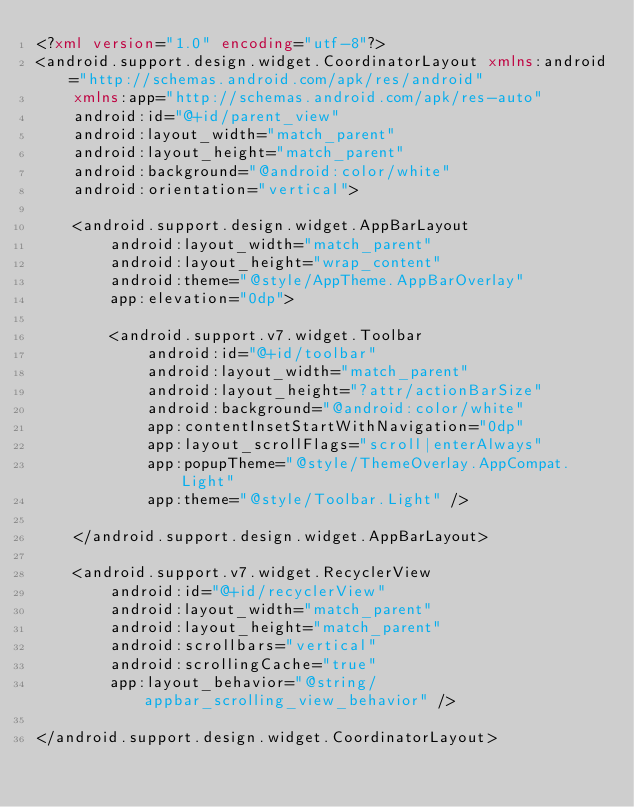<code> <loc_0><loc_0><loc_500><loc_500><_XML_><?xml version="1.0" encoding="utf-8"?>
<android.support.design.widget.CoordinatorLayout xmlns:android="http://schemas.android.com/apk/res/android"
    xmlns:app="http://schemas.android.com/apk/res-auto"
    android:id="@+id/parent_view"
    android:layout_width="match_parent"
    android:layout_height="match_parent"
    android:background="@android:color/white"
    android:orientation="vertical">

    <android.support.design.widget.AppBarLayout
        android:layout_width="match_parent"
        android:layout_height="wrap_content"
        android:theme="@style/AppTheme.AppBarOverlay"
        app:elevation="0dp">

        <android.support.v7.widget.Toolbar
            android:id="@+id/toolbar"
            android:layout_width="match_parent"
            android:layout_height="?attr/actionBarSize"
            android:background="@android:color/white"
            app:contentInsetStartWithNavigation="0dp"
            app:layout_scrollFlags="scroll|enterAlways"
            app:popupTheme="@style/ThemeOverlay.AppCompat.Light"
            app:theme="@style/Toolbar.Light" />

    </android.support.design.widget.AppBarLayout>

    <android.support.v7.widget.RecyclerView
        android:id="@+id/recyclerView"
        android:layout_width="match_parent"
        android:layout_height="match_parent"
        android:scrollbars="vertical"
        android:scrollingCache="true"
        app:layout_behavior="@string/appbar_scrolling_view_behavior" />

</android.support.design.widget.CoordinatorLayout>



</code> 